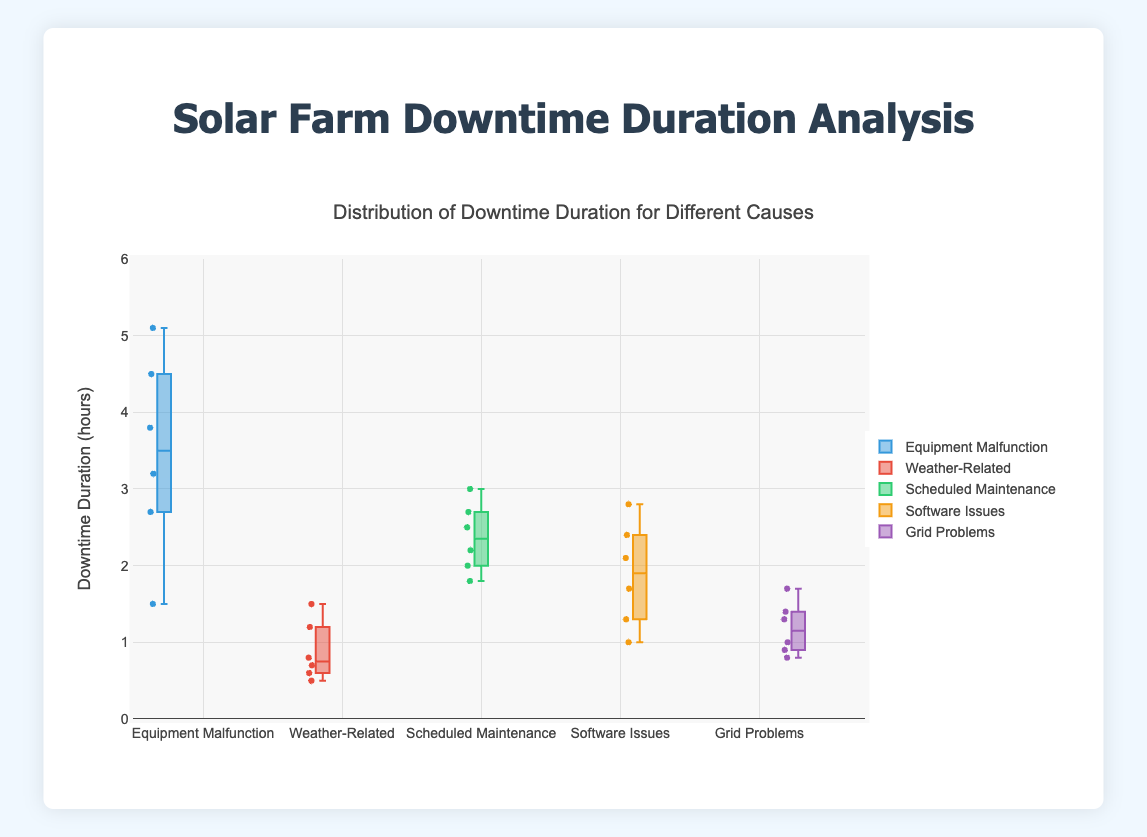What is the title of the figure? The title is typically at the top center of the figure. Here it reads, "Distribution of Downtime Duration for Different Causes".
Answer: Distribution of Downtime Duration for Different Causes What does the y-axis represent? The label on the y-axis shows "Downtime Duration (hours)".
Answer: Downtime Duration (hours) Which cause has the widest range of downtime duration? The "Equipment Malfunction" box plot is the tallest, indicating the widest range of downtime duration.
Answer: Equipment Malfunction What is the median downtime duration for Weather-Related issues? In a box plot, the median is represented by the line inside the box. For "Weather-Related", this line is at approximately 0.85 hours.
Answer: 0.85 hours How many causes have a median downtime duration above 2 hours? By looking at the median lines inside the boxes, "Equipment Malfunction", "Scheduled Maintenance", and "Software Issues" have medians above 2 hours.
Answer: 3 Which cause has the smallest interquartile range (IQR) of downtime duration? The box for "Weather-Related" is the shortest, indicating the smallest IQR.
Answer: Weather-Related Which cause has the highest upper whisker and what is its value? The upper whisker extends to the highest value excluding outliers. "Equipment Malfunction" has the highest upper whisker, reaching 5.1 hours.
Answer: Equipment Malfunction, 5.1 hours What is the difference between the median downtime of Equipment Malfunction and Software Issues? The median downtime for "Equipment Malfunction" is around 3.2 hours, and for "Software Issues" is around 2.1 hours. The difference is 3.2 - 2.1 = 1.1 hours.
Answer: 1.1 hours Which cause has the lowest lower whisker and what is its value? The lower whisker extends to the lowest value excluding outliers. "Weather-Related" has the lowest lower whisker, reaching 0.5 hours.
Answer: Weather-Related, 0.5 hours 